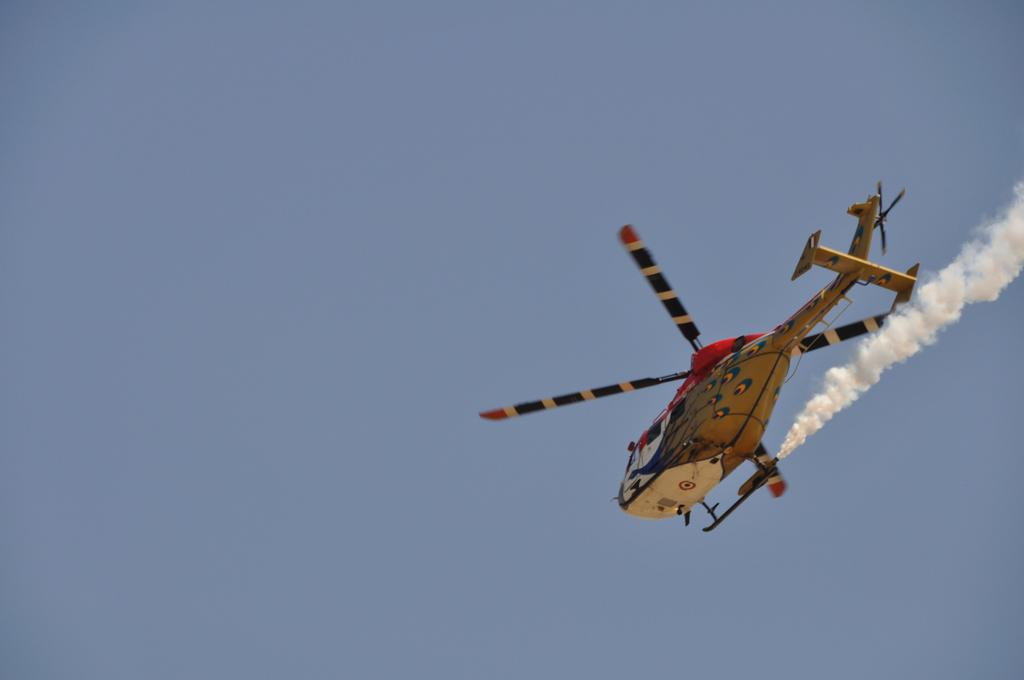What is the main subject of the image? The main subject of the image is a helicopter. What is the helicopter doing in the image? The helicopter is flying in the sky. What else can be seen in the image besides the helicopter? There is smoke visible in the image. What type of glove is the judge wearing in the image? There is no judge or glove present in the image; it features a helicopter flying in the sky with smoke visible. 